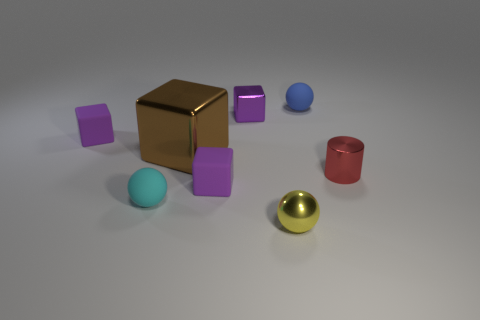Are there any tiny rubber cubes of the same color as the small metallic cube?
Provide a succinct answer. Yes. The tiny shiny object that is on the right side of the tiny sphere that is behind the object to the left of the tiny cyan object is what color?
Your answer should be very brief. Red. Do the cyan rubber object and the tiny red thing have the same shape?
Your answer should be very brief. No. The other small sphere that is the same material as the tiny blue sphere is what color?
Offer a terse response. Cyan. What number of objects are tiny shiny objects to the right of the purple metallic cube or tiny purple metal cubes?
Your answer should be compact. 3. What is the size of the purple object to the left of the small cyan sphere?
Offer a very short reply. Small. Does the red metallic object have the same size as the rubber cube to the left of the cyan ball?
Give a very brief answer. Yes. There is a tiny matte ball that is in front of the rubber sphere to the right of the small yellow thing; what is its color?
Offer a terse response. Cyan. What number of other objects are there of the same color as the big object?
Offer a terse response. 0. What is the size of the yellow metallic ball?
Give a very brief answer. Small. 